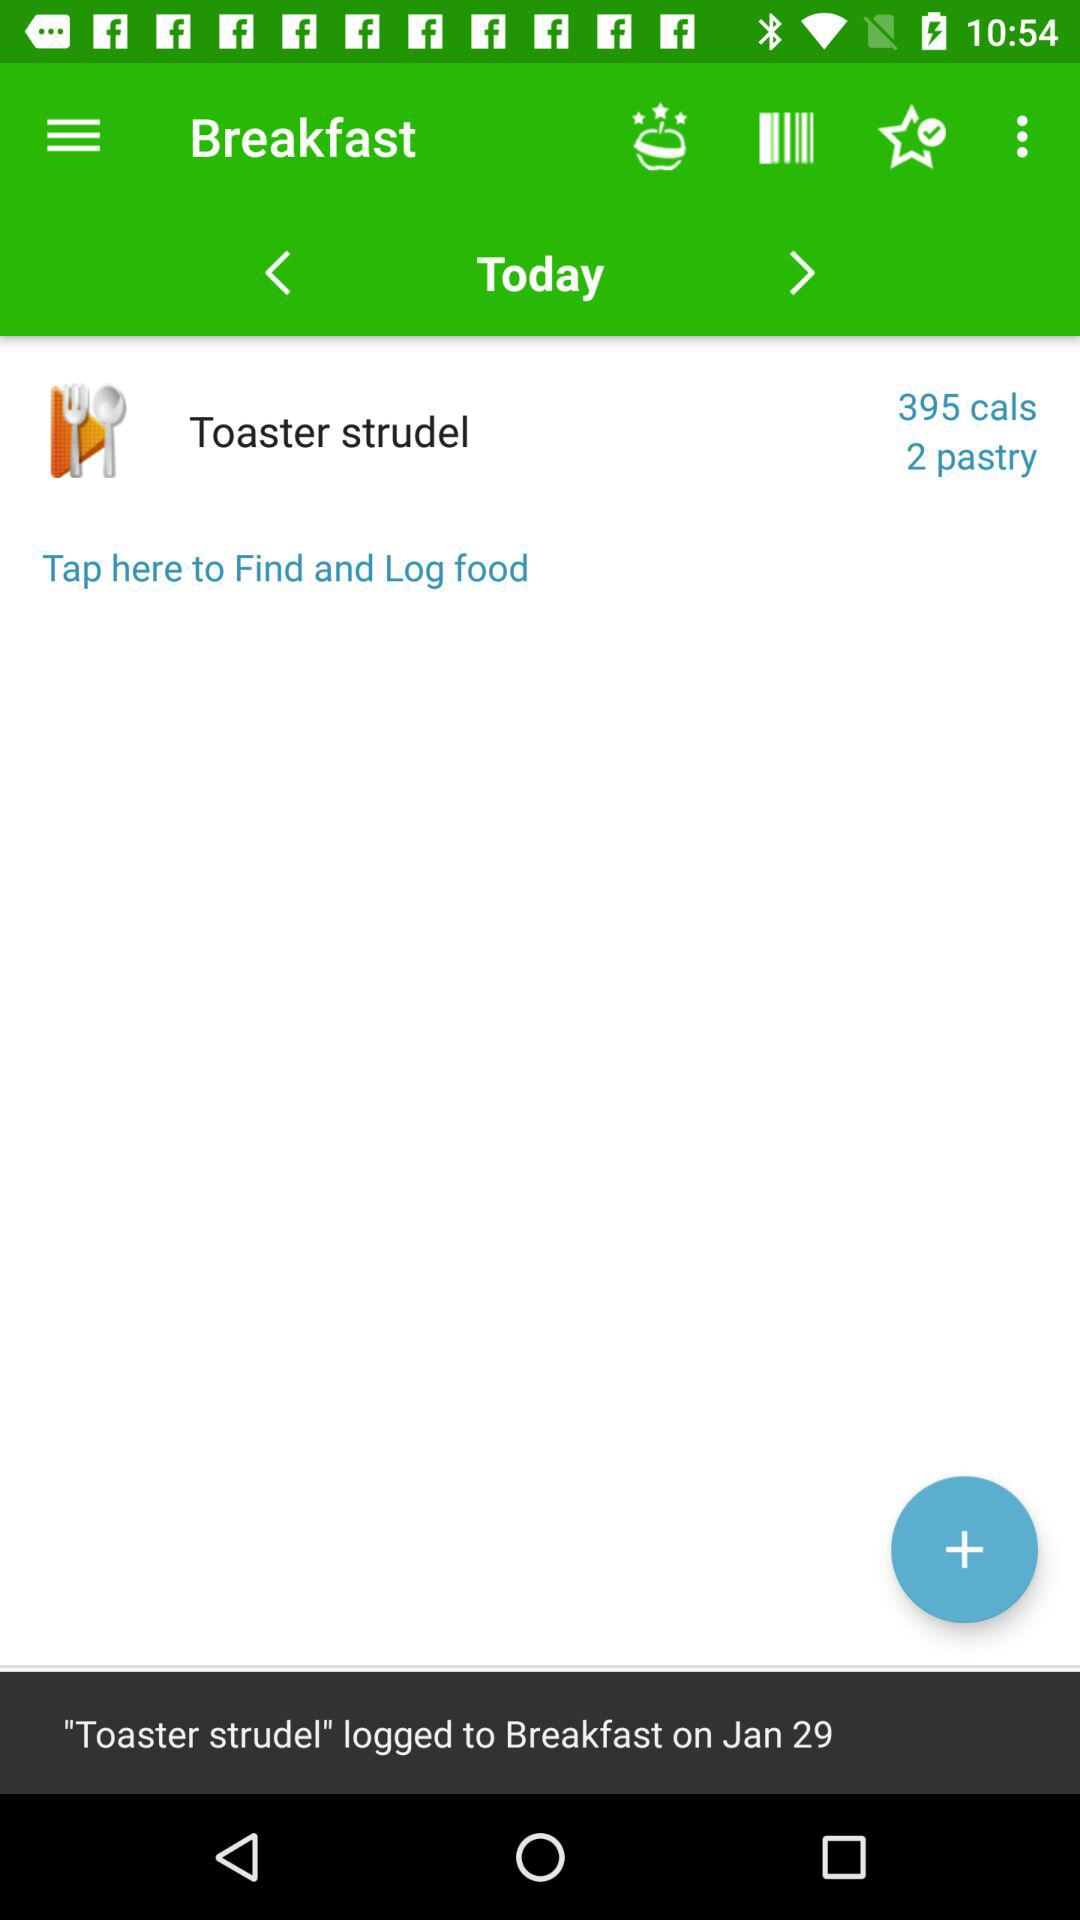How many pastries are there?
Answer the question using a single word or phrase. 2 